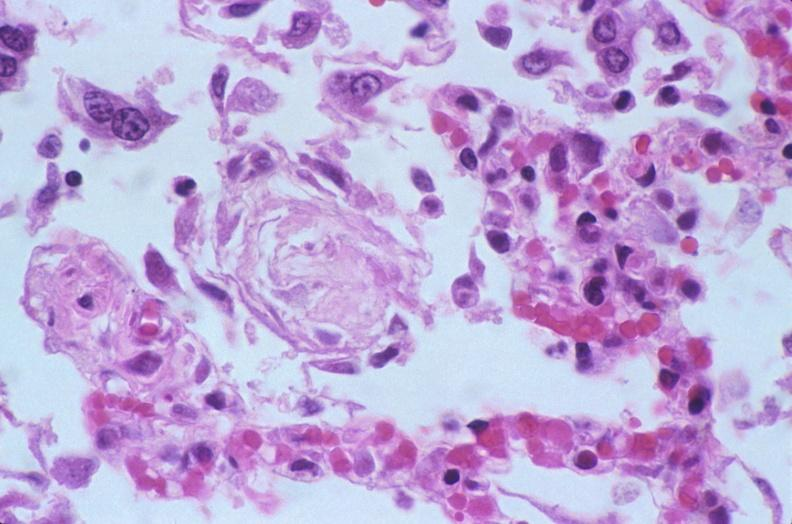what is present?
Answer the question using a single word or phrase. Respiratory 